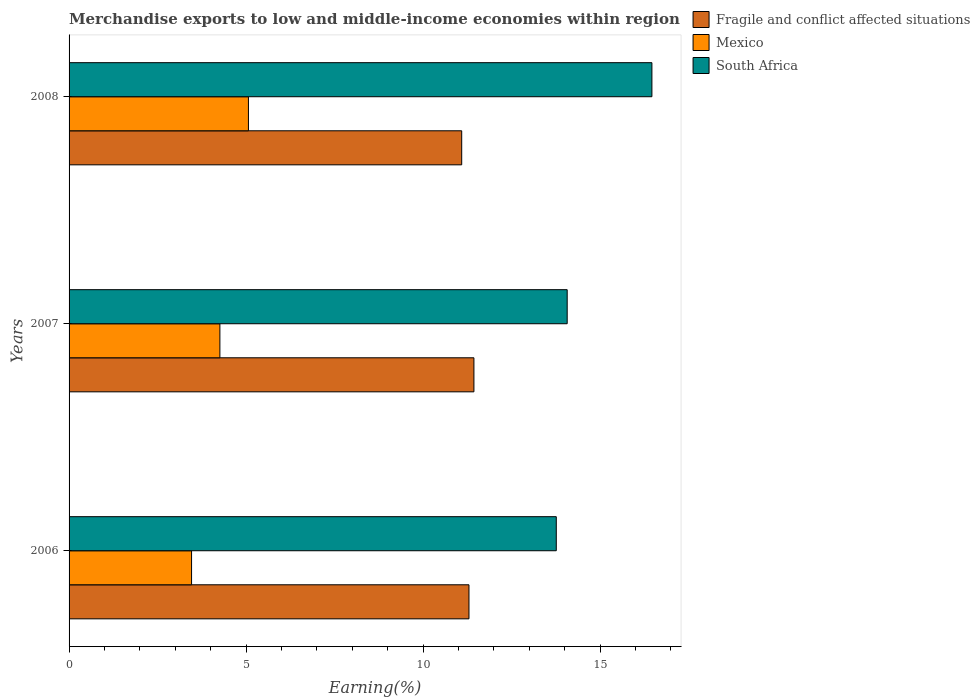How many different coloured bars are there?
Give a very brief answer. 3. Are the number of bars per tick equal to the number of legend labels?
Give a very brief answer. Yes. Are the number of bars on each tick of the Y-axis equal?
Give a very brief answer. Yes. How many bars are there on the 2nd tick from the top?
Give a very brief answer. 3. How many bars are there on the 2nd tick from the bottom?
Your answer should be very brief. 3. What is the percentage of amount earned from merchandise exports in South Africa in 2008?
Provide a short and direct response. 16.46. Across all years, what is the maximum percentage of amount earned from merchandise exports in Mexico?
Your response must be concise. 5.07. Across all years, what is the minimum percentage of amount earned from merchandise exports in Fragile and conflict affected situations?
Make the answer very short. 11.09. What is the total percentage of amount earned from merchandise exports in Fragile and conflict affected situations in the graph?
Your response must be concise. 33.82. What is the difference between the percentage of amount earned from merchandise exports in Mexico in 2007 and that in 2008?
Keep it short and to the point. -0.81. What is the difference between the percentage of amount earned from merchandise exports in Fragile and conflict affected situations in 2008 and the percentage of amount earned from merchandise exports in South Africa in 2007?
Your response must be concise. -2.98. What is the average percentage of amount earned from merchandise exports in Fragile and conflict affected situations per year?
Keep it short and to the point. 11.27. In the year 2008, what is the difference between the percentage of amount earned from merchandise exports in Fragile and conflict affected situations and percentage of amount earned from merchandise exports in Mexico?
Your answer should be very brief. 6.02. In how many years, is the percentage of amount earned from merchandise exports in South Africa greater than 15 %?
Offer a terse response. 1. What is the ratio of the percentage of amount earned from merchandise exports in Mexico in 2007 to that in 2008?
Your answer should be compact. 0.84. Is the percentage of amount earned from merchandise exports in Mexico in 2006 less than that in 2008?
Give a very brief answer. Yes. What is the difference between the highest and the second highest percentage of amount earned from merchandise exports in Mexico?
Offer a terse response. 0.81. What is the difference between the highest and the lowest percentage of amount earned from merchandise exports in Mexico?
Offer a very short reply. 1.61. What does the 2nd bar from the top in 2007 represents?
Provide a short and direct response. Mexico. What does the 3rd bar from the bottom in 2007 represents?
Your answer should be very brief. South Africa. Is it the case that in every year, the sum of the percentage of amount earned from merchandise exports in South Africa and percentage of amount earned from merchandise exports in Fragile and conflict affected situations is greater than the percentage of amount earned from merchandise exports in Mexico?
Offer a terse response. Yes. How many bars are there?
Ensure brevity in your answer.  9. Does the graph contain any zero values?
Offer a terse response. No. How many legend labels are there?
Offer a terse response. 3. What is the title of the graph?
Your answer should be compact. Merchandise exports to low and middle-income economies within region. What is the label or title of the X-axis?
Keep it short and to the point. Earning(%). What is the Earning(%) in Fragile and conflict affected situations in 2006?
Keep it short and to the point. 11.29. What is the Earning(%) of Mexico in 2006?
Your response must be concise. 3.46. What is the Earning(%) in South Africa in 2006?
Provide a short and direct response. 13.76. What is the Earning(%) of Fragile and conflict affected situations in 2007?
Keep it short and to the point. 11.43. What is the Earning(%) of Mexico in 2007?
Provide a short and direct response. 4.26. What is the Earning(%) in South Africa in 2007?
Ensure brevity in your answer.  14.07. What is the Earning(%) in Fragile and conflict affected situations in 2008?
Provide a succinct answer. 11.09. What is the Earning(%) of Mexico in 2008?
Keep it short and to the point. 5.07. What is the Earning(%) of South Africa in 2008?
Ensure brevity in your answer.  16.46. Across all years, what is the maximum Earning(%) of Fragile and conflict affected situations?
Offer a terse response. 11.43. Across all years, what is the maximum Earning(%) in Mexico?
Offer a very short reply. 5.07. Across all years, what is the maximum Earning(%) of South Africa?
Provide a succinct answer. 16.46. Across all years, what is the minimum Earning(%) of Fragile and conflict affected situations?
Provide a short and direct response. 11.09. Across all years, what is the minimum Earning(%) of Mexico?
Ensure brevity in your answer.  3.46. Across all years, what is the minimum Earning(%) of South Africa?
Offer a terse response. 13.76. What is the total Earning(%) in Fragile and conflict affected situations in the graph?
Your response must be concise. 33.82. What is the total Earning(%) of Mexico in the graph?
Give a very brief answer. 12.78. What is the total Earning(%) in South Africa in the graph?
Make the answer very short. 44.29. What is the difference between the Earning(%) of Fragile and conflict affected situations in 2006 and that in 2007?
Your answer should be very brief. -0.14. What is the difference between the Earning(%) in Mexico in 2006 and that in 2007?
Offer a very short reply. -0.8. What is the difference between the Earning(%) of South Africa in 2006 and that in 2007?
Make the answer very short. -0.31. What is the difference between the Earning(%) in Fragile and conflict affected situations in 2006 and that in 2008?
Make the answer very short. 0.21. What is the difference between the Earning(%) of Mexico in 2006 and that in 2008?
Give a very brief answer. -1.61. What is the difference between the Earning(%) of South Africa in 2006 and that in 2008?
Ensure brevity in your answer.  -2.7. What is the difference between the Earning(%) in Fragile and conflict affected situations in 2007 and that in 2008?
Keep it short and to the point. 0.34. What is the difference between the Earning(%) of Mexico in 2007 and that in 2008?
Offer a terse response. -0.81. What is the difference between the Earning(%) of South Africa in 2007 and that in 2008?
Ensure brevity in your answer.  -2.39. What is the difference between the Earning(%) of Fragile and conflict affected situations in 2006 and the Earning(%) of Mexico in 2007?
Your answer should be very brief. 7.04. What is the difference between the Earning(%) in Fragile and conflict affected situations in 2006 and the Earning(%) in South Africa in 2007?
Your answer should be very brief. -2.77. What is the difference between the Earning(%) in Mexico in 2006 and the Earning(%) in South Africa in 2007?
Your response must be concise. -10.61. What is the difference between the Earning(%) of Fragile and conflict affected situations in 2006 and the Earning(%) of Mexico in 2008?
Your answer should be compact. 6.23. What is the difference between the Earning(%) of Fragile and conflict affected situations in 2006 and the Earning(%) of South Africa in 2008?
Give a very brief answer. -5.17. What is the difference between the Earning(%) in Mexico in 2006 and the Earning(%) in South Africa in 2008?
Offer a terse response. -13. What is the difference between the Earning(%) in Fragile and conflict affected situations in 2007 and the Earning(%) in Mexico in 2008?
Give a very brief answer. 6.37. What is the difference between the Earning(%) of Fragile and conflict affected situations in 2007 and the Earning(%) of South Africa in 2008?
Keep it short and to the point. -5.03. What is the difference between the Earning(%) in Mexico in 2007 and the Earning(%) in South Africa in 2008?
Your answer should be very brief. -12.2. What is the average Earning(%) in Fragile and conflict affected situations per year?
Ensure brevity in your answer.  11.27. What is the average Earning(%) in Mexico per year?
Offer a very short reply. 4.26. What is the average Earning(%) of South Africa per year?
Ensure brevity in your answer.  14.76. In the year 2006, what is the difference between the Earning(%) in Fragile and conflict affected situations and Earning(%) in Mexico?
Give a very brief answer. 7.83. In the year 2006, what is the difference between the Earning(%) of Fragile and conflict affected situations and Earning(%) of South Africa?
Give a very brief answer. -2.47. In the year 2006, what is the difference between the Earning(%) of Mexico and Earning(%) of South Africa?
Make the answer very short. -10.3. In the year 2007, what is the difference between the Earning(%) in Fragile and conflict affected situations and Earning(%) in Mexico?
Provide a succinct answer. 7.17. In the year 2007, what is the difference between the Earning(%) of Fragile and conflict affected situations and Earning(%) of South Africa?
Your response must be concise. -2.63. In the year 2007, what is the difference between the Earning(%) in Mexico and Earning(%) in South Africa?
Provide a short and direct response. -9.81. In the year 2008, what is the difference between the Earning(%) in Fragile and conflict affected situations and Earning(%) in Mexico?
Offer a very short reply. 6.02. In the year 2008, what is the difference between the Earning(%) in Fragile and conflict affected situations and Earning(%) in South Africa?
Make the answer very short. -5.37. In the year 2008, what is the difference between the Earning(%) in Mexico and Earning(%) in South Africa?
Give a very brief answer. -11.4. What is the ratio of the Earning(%) of Fragile and conflict affected situations in 2006 to that in 2007?
Offer a very short reply. 0.99. What is the ratio of the Earning(%) of Mexico in 2006 to that in 2007?
Your answer should be compact. 0.81. What is the ratio of the Earning(%) in South Africa in 2006 to that in 2007?
Give a very brief answer. 0.98. What is the ratio of the Earning(%) of Fragile and conflict affected situations in 2006 to that in 2008?
Keep it short and to the point. 1.02. What is the ratio of the Earning(%) in Mexico in 2006 to that in 2008?
Provide a succinct answer. 0.68. What is the ratio of the Earning(%) of South Africa in 2006 to that in 2008?
Your answer should be very brief. 0.84. What is the ratio of the Earning(%) of Fragile and conflict affected situations in 2007 to that in 2008?
Provide a short and direct response. 1.03. What is the ratio of the Earning(%) in Mexico in 2007 to that in 2008?
Keep it short and to the point. 0.84. What is the ratio of the Earning(%) of South Africa in 2007 to that in 2008?
Keep it short and to the point. 0.85. What is the difference between the highest and the second highest Earning(%) of Fragile and conflict affected situations?
Make the answer very short. 0.14. What is the difference between the highest and the second highest Earning(%) in Mexico?
Your answer should be compact. 0.81. What is the difference between the highest and the second highest Earning(%) in South Africa?
Ensure brevity in your answer.  2.39. What is the difference between the highest and the lowest Earning(%) in Fragile and conflict affected situations?
Your answer should be very brief. 0.34. What is the difference between the highest and the lowest Earning(%) of Mexico?
Offer a very short reply. 1.61. What is the difference between the highest and the lowest Earning(%) in South Africa?
Your response must be concise. 2.7. 